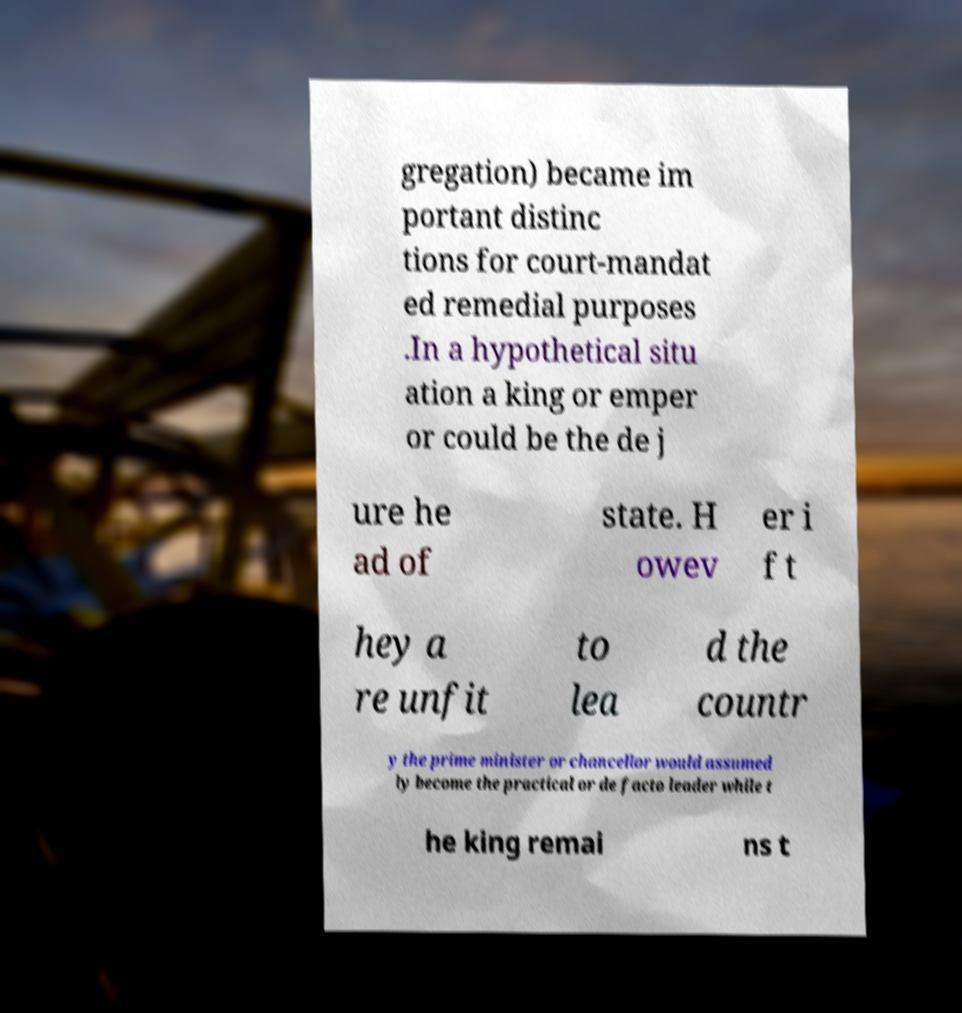Can you read and provide the text displayed in the image?This photo seems to have some interesting text. Can you extract and type it out for me? gregation) became im portant distinc tions for court-mandat ed remedial purposes .In a hypothetical situ ation a king or emper or could be the de j ure he ad of state. H owev er i f t hey a re unfit to lea d the countr y the prime minister or chancellor would assumed ly become the practical or de facto leader while t he king remai ns t 